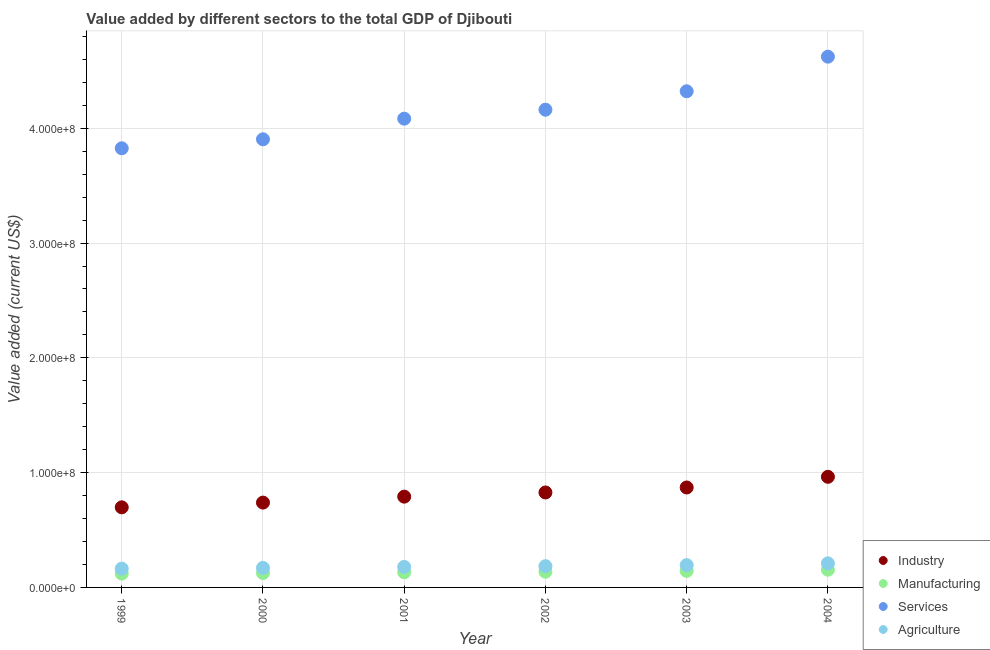How many different coloured dotlines are there?
Offer a terse response. 4. What is the value added by industrial sector in 2003?
Your answer should be very brief. 8.71e+07. Across all years, what is the maximum value added by manufacturing sector?
Offer a terse response. 1.54e+07. Across all years, what is the minimum value added by industrial sector?
Make the answer very short. 6.98e+07. In which year was the value added by industrial sector maximum?
Offer a very short reply. 2004. What is the total value added by agricultural sector in the graph?
Provide a short and direct response. 1.10e+08. What is the difference between the value added by manufacturing sector in 2002 and that in 2003?
Ensure brevity in your answer.  -7.02e+05. What is the difference between the value added by industrial sector in 1999 and the value added by manufacturing sector in 2004?
Your response must be concise. 5.44e+07. What is the average value added by services sector per year?
Keep it short and to the point. 4.15e+08. In the year 1999, what is the difference between the value added by manufacturing sector and value added by services sector?
Your answer should be compact. -3.70e+08. What is the ratio of the value added by agricultural sector in 2001 to that in 2003?
Provide a succinct answer. 0.92. Is the value added by manufacturing sector in 1999 less than that in 2003?
Provide a succinct answer. Yes. What is the difference between the highest and the second highest value added by agricultural sector?
Your answer should be very brief. 1.51e+06. What is the difference between the highest and the lowest value added by agricultural sector?
Offer a very short reply. 4.62e+06. In how many years, is the value added by manufacturing sector greater than the average value added by manufacturing sector taken over all years?
Your answer should be very brief. 3. Is the sum of the value added by industrial sector in 2000 and 2001 greater than the maximum value added by services sector across all years?
Your response must be concise. No. Is the value added by agricultural sector strictly greater than the value added by industrial sector over the years?
Your response must be concise. No. Is the value added by industrial sector strictly less than the value added by services sector over the years?
Ensure brevity in your answer.  Yes. Does the graph contain any zero values?
Offer a very short reply. No. What is the title of the graph?
Keep it short and to the point. Value added by different sectors to the total GDP of Djibouti. What is the label or title of the Y-axis?
Offer a very short reply. Value added (current US$). What is the Value added (current US$) in Industry in 1999?
Offer a terse response. 6.98e+07. What is the Value added (current US$) in Manufacturing in 1999?
Give a very brief answer. 1.21e+07. What is the Value added (current US$) of Services in 1999?
Keep it short and to the point. 3.83e+08. What is the Value added (current US$) in Agriculture in 1999?
Your answer should be very brief. 1.64e+07. What is the Value added (current US$) in Industry in 2000?
Your answer should be very brief. 7.39e+07. What is the Value added (current US$) of Manufacturing in 2000?
Make the answer very short. 1.26e+07. What is the Value added (current US$) in Services in 2000?
Make the answer very short. 3.90e+08. What is the Value added (current US$) in Agriculture in 2000?
Give a very brief answer. 1.71e+07. What is the Value added (current US$) of Industry in 2001?
Your response must be concise. 7.91e+07. What is the Value added (current US$) in Manufacturing in 2001?
Your response must be concise. 1.32e+07. What is the Value added (current US$) in Services in 2001?
Make the answer very short. 4.08e+08. What is the Value added (current US$) of Agriculture in 2001?
Give a very brief answer. 1.79e+07. What is the Value added (current US$) of Industry in 2002?
Offer a terse response. 8.27e+07. What is the Value added (current US$) in Manufacturing in 2002?
Provide a succinct answer. 1.37e+07. What is the Value added (current US$) in Services in 2002?
Your answer should be compact. 4.16e+08. What is the Value added (current US$) in Agriculture in 2002?
Your answer should be very brief. 1.85e+07. What is the Value added (current US$) in Industry in 2003?
Your answer should be very brief. 8.71e+07. What is the Value added (current US$) of Manufacturing in 2003?
Give a very brief answer. 1.44e+07. What is the Value added (current US$) of Services in 2003?
Provide a succinct answer. 4.32e+08. What is the Value added (current US$) in Agriculture in 2003?
Provide a short and direct response. 1.95e+07. What is the Value added (current US$) of Industry in 2004?
Ensure brevity in your answer.  9.64e+07. What is the Value added (current US$) of Manufacturing in 2004?
Keep it short and to the point. 1.54e+07. What is the Value added (current US$) of Services in 2004?
Give a very brief answer. 4.62e+08. What is the Value added (current US$) in Agriculture in 2004?
Provide a succinct answer. 2.10e+07. Across all years, what is the maximum Value added (current US$) in Industry?
Ensure brevity in your answer.  9.64e+07. Across all years, what is the maximum Value added (current US$) in Manufacturing?
Ensure brevity in your answer.  1.54e+07. Across all years, what is the maximum Value added (current US$) of Services?
Your answer should be very brief. 4.62e+08. Across all years, what is the maximum Value added (current US$) in Agriculture?
Provide a short and direct response. 2.10e+07. Across all years, what is the minimum Value added (current US$) of Industry?
Ensure brevity in your answer.  6.98e+07. Across all years, what is the minimum Value added (current US$) of Manufacturing?
Offer a very short reply. 1.21e+07. Across all years, what is the minimum Value added (current US$) of Services?
Your response must be concise. 3.83e+08. Across all years, what is the minimum Value added (current US$) in Agriculture?
Keep it short and to the point. 1.64e+07. What is the total Value added (current US$) in Industry in the graph?
Offer a terse response. 4.89e+08. What is the total Value added (current US$) of Manufacturing in the graph?
Offer a terse response. 8.13e+07. What is the total Value added (current US$) of Services in the graph?
Make the answer very short. 2.49e+09. What is the total Value added (current US$) of Agriculture in the graph?
Offer a terse response. 1.10e+08. What is the difference between the Value added (current US$) of Industry in 1999 and that in 2000?
Your answer should be compact. -4.11e+06. What is the difference between the Value added (current US$) of Manufacturing in 1999 and that in 2000?
Give a very brief answer. -4.83e+05. What is the difference between the Value added (current US$) in Services in 1999 and that in 2000?
Provide a succinct answer. -7.82e+06. What is the difference between the Value added (current US$) of Agriculture in 1999 and that in 2000?
Ensure brevity in your answer.  -7.03e+05. What is the difference between the Value added (current US$) in Industry in 1999 and that in 2001?
Provide a succinct answer. -9.30e+06. What is the difference between the Value added (current US$) of Manufacturing in 1999 and that in 2001?
Give a very brief answer. -1.10e+06. What is the difference between the Value added (current US$) of Services in 1999 and that in 2001?
Keep it short and to the point. -2.58e+07. What is the difference between the Value added (current US$) of Agriculture in 1999 and that in 2001?
Offer a terse response. -1.52e+06. What is the difference between the Value added (current US$) in Industry in 1999 and that in 2002?
Give a very brief answer. -1.29e+07. What is the difference between the Value added (current US$) in Manufacturing in 1999 and that in 2002?
Keep it short and to the point. -1.60e+06. What is the difference between the Value added (current US$) of Services in 1999 and that in 2002?
Provide a succinct answer. -3.36e+07. What is the difference between the Value added (current US$) of Agriculture in 1999 and that in 2002?
Ensure brevity in your answer.  -2.18e+06. What is the difference between the Value added (current US$) in Industry in 1999 and that in 2003?
Provide a succinct answer. -1.73e+07. What is the difference between the Value added (current US$) of Manufacturing in 1999 and that in 2003?
Your response must be concise. -2.30e+06. What is the difference between the Value added (current US$) in Services in 1999 and that in 2003?
Give a very brief answer. -4.97e+07. What is the difference between the Value added (current US$) of Agriculture in 1999 and that in 2003?
Keep it short and to the point. -3.11e+06. What is the difference between the Value added (current US$) in Industry in 1999 and that in 2004?
Ensure brevity in your answer.  -2.66e+07. What is the difference between the Value added (current US$) in Manufacturing in 1999 and that in 2004?
Provide a succinct answer. -3.34e+06. What is the difference between the Value added (current US$) in Services in 1999 and that in 2004?
Your answer should be compact. -7.98e+07. What is the difference between the Value added (current US$) in Agriculture in 1999 and that in 2004?
Provide a succinct answer. -4.62e+06. What is the difference between the Value added (current US$) of Industry in 2000 and that in 2001?
Ensure brevity in your answer.  -5.19e+06. What is the difference between the Value added (current US$) in Manufacturing in 2000 and that in 2001?
Keep it short and to the point. -6.18e+05. What is the difference between the Value added (current US$) of Services in 2000 and that in 2001?
Provide a short and direct response. -1.80e+07. What is the difference between the Value added (current US$) of Agriculture in 2000 and that in 2001?
Your response must be concise. -8.21e+05. What is the difference between the Value added (current US$) in Industry in 2000 and that in 2002?
Ensure brevity in your answer.  -8.84e+06. What is the difference between the Value added (current US$) of Manufacturing in 2000 and that in 2002?
Give a very brief answer. -1.11e+06. What is the difference between the Value added (current US$) in Services in 2000 and that in 2002?
Make the answer very short. -2.58e+07. What is the difference between the Value added (current US$) of Agriculture in 2000 and that in 2002?
Provide a short and direct response. -1.47e+06. What is the difference between the Value added (current US$) of Industry in 2000 and that in 2003?
Offer a terse response. -1.32e+07. What is the difference between the Value added (current US$) of Manufacturing in 2000 and that in 2003?
Your answer should be compact. -1.81e+06. What is the difference between the Value added (current US$) in Services in 2000 and that in 2003?
Provide a succinct answer. -4.19e+07. What is the difference between the Value added (current US$) of Agriculture in 2000 and that in 2003?
Offer a terse response. -2.41e+06. What is the difference between the Value added (current US$) in Industry in 2000 and that in 2004?
Your response must be concise. -2.25e+07. What is the difference between the Value added (current US$) of Manufacturing in 2000 and that in 2004?
Provide a short and direct response. -2.86e+06. What is the difference between the Value added (current US$) of Services in 2000 and that in 2004?
Make the answer very short. -7.20e+07. What is the difference between the Value added (current US$) in Agriculture in 2000 and that in 2004?
Offer a terse response. -3.92e+06. What is the difference between the Value added (current US$) in Industry in 2001 and that in 2002?
Your answer should be compact. -3.65e+06. What is the difference between the Value added (current US$) in Manufacturing in 2001 and that in 2002?
Make the answer very short. -4.95e+05. What is the difference between the Value added (current US$) of Services in 2001 and that in 2002?
Ensure brevity in your answer.  -7.81e+06. What is the difference between the Value added (current US$) of Agriculture in 2001 and that in 2002?
Your answer should be very brief. -6.53e+05. What is the difference between the Value added (current US$) in Industry in 2001 and that in 2003?
Provide a short and direct response. -7.98e+06. What is the difference between the Value added (current US$) of Manufacturing in 2001 and that in 2003?
Offer a terse response. -1.20e+06. What is the difference between the Value added (current US$) in Services in 2001 and that in 2003?
Give a very brief answer. -2.39e+07. What is the difference between the Value added (current US$) of Agriculture in 2001 and that in 2003?
Keep it short and to the point. -1.59e+06. What is the difference between the Value added (current US$) in Industry in 2001 and that in 2004?
Your answer should be compact. -1.73e+07. What is the difference between the Value added (current US$) in Manufacturing in 2001 and that in 2004?
Offer a terse response. -2.24e+06. What is the difference between the Value added (current US$) of Services in 2001 and that in 2004?
Your answer should be compact. -5.40e+07. What is the difference between the Value added (current US$) of Agriculture in 2001 and that in 2004?
Give a very brief answer. -3.10e+06. What is the difference between the Value added (current US$) of Industry in 2002 and that in 2003?
Make the answer very short. -4.33e+06. What is the difference between the Value added (current US$) of Manufacturing in 2002 and that in 2003?
Provide a succinct answer. -7.02e+05. What is the difference between the Value added (current US$) in Services in 2002 and that in 2003?
Offer a very short reply. -1.61e+07. What is the difference between the Value added (current US$) of Agriculture in 2002 and that in 2003?
Offer a very short reply. -9.32e+05. What is the difference between the Value added (current US$) in Industry in 2002 and that in 2004?
Give a very brief answer. -1.36e+07. What is the difference between the Value added (current US$) in Manufacturing in 2002 and that in 2004?
Offer a terse response. -1.75e+06. What is the difference between the Value added (current US$) of Services in 2002 and that in 2004?
Offer a terse response. -4.62e+07. What is the difference between the Value added (current US$) of Agriculture in 2002 and that in 2004?
Make the answer very short. -2.44e+06. What is the difference between the Value added (current US$) in Industry in 2003 and that in 2004?
Your answer should be compact. -9.30e+06. What is the difference between the Value added (current US$) of Manufacturing in 2003 and that in 2004?
Your answer should be very brief. -1.04e+06. What is the difference between the Value added (current US$) of Services in 2003 and that in 2004?
Provide a succinct answer. -3.01e+07. What is the difference between the Value added (current US$) in Agriculture in 2003 and that in 2004?
Offer a terse response. -1.51e+06. What is the difference between the Value added (current US$) in Industry in 1999 and the Value added (current US$) in Manufacturing in 2000?
Ensure brevity in your answer.  5.72e+07. What is the difference between the Value added (current US$) in Industry in 1999 and the Value added (current US$) in Services in 2000?
Your answer should be compact. -3.21e+08. What is the difference between the Value added (current US$) of Industry in 1999 and the Value added (current US$) of Agriculture in 2000?
Provide a succinct answer. 5.27e+07. What is the difference between the Value added (current US$) in Manufacturing in 1999 and the Value added (current US$) in Services in 2000?
Provide a succinct answer. -3.78e+08. What is the difference between the Value added (current US$) in Manufacturing in 1999 and the Value added (current US$) in Agriculture in 2000?
Provide a short and direct response. -4.97e+06. What is the difference between the Value added (current US$) in Services in 1999 and the Value added (current US$) in Agriculture in 2000?
Ensure brevity in your answer.  3.66e+08. What is the difference between the Value added (current US$) of Industry in 1999 and the Value added (current US$) of Manufacturing in 2001?
Offer a terse response. 5.66e+07. What is the difference between the Value added (current US$) of Industry in 1999 and the Value added (current US$) of Services in 2001?
Your response must be concise. -3.39e+08. What is the difference between the Value added (current US$) of Industry in 1999 and the Value added (current US$) of Agriculture in 2001?
Your answer should be compact. 5.19e+07. What is the difference between the Value added (current US$) in Manufacturing in 1999 and the Value added (current US$) in Services in 2001?
Provide a short and direct response. -3.96e+08. What is the difference between the Value added (current US$) of Manufacturing in 1999 and the Value added (current US$) of Agriculture in 2001?
Give a very brief answer. -5.80e+06. What is the difference between the Value added (current US$) of Services in 1999 and the Value added (current US$) of Agriculture in 2001?
Provide a succinct answer. 3.65e+08. What is the difference between the Value added (current US$) in Industry in 1999 and the Value added (current US$) in Manufacturing in 2002?
Your answer should be very brief. 5.61e+07. What is the difference between the Value added (current US$) in Industry in 1999 and the Value added (current US$) in Services in 2002?
Give a very brief answer. -3.46e+08. What is the difference between the Value added (current US$) of Industry in 1999 and the Value added (current US$) of Agriculture in 2002?
Ensure brevity in your answer.  5.13e+07. What is the difference between the Value added (current US$) in Manufacturing in 1999 and the Value added (current US$) in Services in 2002?
Give a very brief answer. -4.04e+08. What is the difference between the Value added (current US$) in Manufacturing in 1999 and the Value added (current US$) in Agriculture in 2002?
Your answer should be very brief. -6.45e+06. What is the difference between the Value added (current US$) of Services in 1999 and the Value added (current US$) of Agriculture in 2002?
Keep it short and to the point. 3.64e+08. What is the difference between the Value added (current US$) in Industry in 1999 and the Value added (current US$) in Manufacturing in 2003?
Your answer should be very brief. 5.54e+07. What is the difference between the Value added (current US$) of Industry in 1999 and the Value added (current US$) of Services in 2003?
Ensure brevity in your answer.  -3.62e+08. What is the difference between the Value added (current US$) of Industry in 1999 and the Value added (current US$) of Agriculture in 2003?
Make the answer very short. 5.03e+07. What is the difference between the Value added (current US$) of Manufacturing in 1999 and the Value added (current US$) of Services in 2003?
Provide a short and direct response. -4.20e+08. What is the difference between the Value added (current US$) of Manufacturing in 1999 and the Value added (current US$) of Agriculture in 2003?
Offer a terse response. -7.38e+06. What is the difference between the Value added (current US$) in Services in 1999 and the Value added (current US$) in Agriculture in 2003?
Offer a terse response. 3.63e+08. What is the difference between the Value added (current US$) of Industry in 1999 and the Value added (current US$) of Manufacturing in 2004?
Provide a short and direct response. 5.44e+07. What is the difference between the Value added (current US$) of Industry in 1999 and the Value added (current US$) of Services in 2004?
Provide a succinct answer. -3.93e+08. What is the difference between the Value added (current US$) of Industry in 1999 and the Value added (current US$) of Agriculture in 2004?
Ensure brevity in your answer.  4.88e+07. What is the difference between the Value added (current US$) of Manufacturing in 1999 and the Value added (current US$) of Services in 2004?
Give a very brief answer. -4.50e+08. What is the difference between the Value added (current US$) of Manufacturing in 1999 and the Value added (current US$) of Agriculture in 2004?
Your answer should be compact. -8.89e+06. What is the difference between the Value added (current US$) of Services in 1999 and the Value added (current US$) of Agriculture in 2004?
Provide a succinct answer. 3.62e+08. What is the difference between the Value added (current US$) in Industry in 2000 and the Value added (current US$) in Manufacturing in 2001?
Your answer should be very brief. 6.07e+07. What is the difference between the Value added (current US$) of Industry in 2000 and the Value added (current US$) of Services in 2001?
Ensure brevity in your answer.  -3.34e+08. What is the difference between the Value added (current US$) in Industry in 2000 and the Value added (current US$) in Agriculture in 2001?
Offer a very short reply. 5.60e+07. What is the difference between the Value added (current US$) in Manufacturing in 2000 and the Value added (current US$) in Services in 2001?
Offer a terse response. -3.96e+08. What is the difference between the Value added (current US$) of Manufacturing in 2000 and the Value added (current US$) of Agriculture in 2001?
Your response must be concise. -5.31e+06. What is the difference between the Value added (current US$) in Services in 2000 and the Value added (current US$) in Agriculture in 2001?
Provide a succinct answer. 3.73e+08. What is the difference between the Value added (current US$) in Industry in 2000 and the Value added (current US$) in Manufacturing in 2002?
Make the answer very short. 6.02e+07. What is the difference between the Value added (current US$) of Industry in 2000 and the Value added (current US$) of Services in 2002?
Offer a terse response. -3.42e+08. What is the difference between the Value added (current US$) in Industry in 2000 and the Value added (current US$) in Agriculture in 2002?
Your response must be concise. 5.54e+07. What is the difference between the Value added (current US$) in Manufacturing in 2000 and the Value added (current US$) in Services in 2002?
Provide a succinct answer. -4.04e+08. What is the difference between the Value added (current US$) of Manufacturing in 2000 and the Value added (current US$) of Agriculture in 2002?
Give a very brief answer. -5.96e+06. What is the difference between the Value added (current US$) of Services in 2000 and the Value added (current US$) of Agriculture in 2002?
Provide a short and direct response. 3.72e+08. What is the difference between the Value added (current US$) in Industry in 2000 and the Value added (current US$) in Manufacturing in 2003?
Provide a succinct answer. 5.95e+07. What is the difference between the Value added (current US$) of Industry in 2000 and the Value added (current US$) of Services in 2003?
Provide a succinct answer. -3.58e+08. What is the difference between the Value added (current US$) of Industry in 2000 and the Value added (current US$) of Agriculture in 2003?
Provide a short and direct response. 5.44e+07. What is the difference between the Value added (current US$) of Manufacturing in 2000 and the Value added (current US$) of Services in 2003?
Your response must be concise. -4.20e+08. What is the difference between the Value added (current US$) in Manufacturing in 2000 and the Value added (current US$) in Agriculture in 2003?
Ensure brevity in your answer.  -6.90e+06. What is the difference between the Value added (current US$) in Services in 2000 and the Value added (current US$) in Agriculture in 2003?
Provide a short and direct response. 3.71e+08. What is the difference between the Value added (current US$) of Industry in 2000 and the Value added (current US$) of Manufacturing in 2004?
Your answer should be very brief. 5.85e+07. What is the difference between the Value added (current US$) of Industry in 2000 and the Value added (current US$) of Services in 2004?
Your answer should be compact. -3.88e+08. What is the difference between the Value added (current US$) in Industry in 2000 and the Value added (current US$) in Agriculture in 2004?
Provide a short and direct response. 5.29e+07. What is the difference between the Value added (current US$) of Manufacturing in 2000 and the Value added (current US$) of Services in 2004?
Give a very brief answer. -4.50e+08. What is the difference between the Value added (current US$) of Manufacturing in 2000 and the Value added (current US$) of Agriculture in 2004?
Provide a short and direct response. -8.41e+06. What is the difference between the Value added (current US$) in Services in 2000 and the Value added (current US$) in Agriculture in 2004?
Ensure brevity in your answer.  3.69e+08. What is the difference between the Value added (current US$) of Industry in 2001 and the Value added (current US$) of Manufacturing in 2002?
Offer a very short reply. 6.54e+07. What is the difference between the Value added (current US$) in Industry in 2001 and the Value added (current US$) in Services in 2002?
Offer a terse response. -3.37e+08. What is the difference between the Value added (current US$) in Industry in 2001 and the Value added (current US$) in Agriculture in 2002?
Offer a terse response. 6.06e+07. What is the difference between the Value added (current US$) in Manufacturing in 2001 and the Value added (current US$) in Services in 2002?
Offer a terse response. -4.03e+08. What is the difference between the Value added (current US$) in Manufacturing in 2001 and the Value added (current US$) in Agriculture in 2002?
Your answer should be compact. -5.35e+06. What is the difference between the Value added (current US$) in Services in 2001 and the Value added (current US$) in Agriculture in 2002?
Your answer should be compact. 3.90e+08. What is the difference between the Value added (current US$) of Industry in 2001 and the Value added (current US$) of Manufacturing in 2003?
Your answer should be compact. 6.47e+07. What is the difference between the Value added (current US$) of Industry in 2001 and the Value added (current US$) of Services in 2003?
Your answer should be compact. -3.53e+08. What is the difference between the Value added (current US$) in Industry in 2001 and the Value added (current US$) in Agriculture in 2003?
Your answer should be compact. 5.96e+07. What is the difference between the Value added (current US$) in Manufacturing in 2001 and the Value added (current US$) in Services in 2003?
Make the answer very short. -4.19e+08. What is the difference between the Value added (current US$) in Manufacturing in 2001 and the Value added (current US$) in Agriculture in 2003?
Provide a succinct answer. -6.28e+06. What is the difference between the Value added (current US$) of Services in 2001 and the Value added (current US$) of Agriculture in 2003?
Give a very brief answer. 3.89e+08. What is the difference between the Value added (current US$) of Industry in 2001 and the Value added (current US$) of Manufacturing in 2004?
Your answer should be very brief. 6.37e+07. What is the difference between the Value added (current US$) in Industry in 2001 and the Value added (current US$) in Services in 2004?
Your answer should be very brief. -3.83e+08. What is the difference between the Value added (current US$) of Industry in 2001 and the Value added (current US$) of Agriculture in 2004?
Provide a succinct answer. 5.81e+07. What is the difference between the Value added (current US$) in Manufacturing in 2001 and the Value added (current US$) in Services in 2004?
Ensure brevity in your answer.  -4.49e+08. What is the difference between the Value added (current US$) of Manufacturing in 2001 and the Value added (current US$) of Agriculture in 2004?
Offer a terse response. -7.79e+06. What is the difference between the Value added (current US$) in Services in 2001 and the Value added (current US$) in Agriculture in 2004?
Your answer should be compact. 3.87e+08. What is the difference between the Value added (current US$) of Industry in 2002 and the Value added (current US$) of Manufacturing in 2003?
Your response must be concise. 6.84e+07. What is the difference between the Value added (current US$) of Industry in 2002 and the Value added (current US$) of Services in 2003?
Make the answer very short. -3.50e+08. What is the difference between the Value added (current US$) of Industry in 2002 and the Value added (current US$) of Agriculture in 2003?
Your answer should be very brief. 6.33e+07. What is the difference between the Value added (current US$) in Manufacturing in 2002 and the Value added (current US$) in Services in 2003?
Your answer should be compact. -4.19e+08. What is the difference between the Value added (current US$) of Manufacturing in 2002 and the Value added (current US$) of Agriculture in 2003?
Offer a terse response. -5.78e+06. What is the difference between the Value added (current US$) in Services in 2002 and the Value added (current US$) in Agriculture in 2003?
Your response must be concise. 3.97e+08. What is the difference between the Value added (current US$) in Industry in 2002 and the Value added (current US$) in Manufacturing in 2004?
Ensure brevity in your answer.  6.73e+07. What is the difference between the Value added (current US$) in Industry in 2002 and the Value added (current US$) in Services in 2004?
Keep it short and to the point. -3.80e+08. What is the difference between the Value added (current US$) of Industry in 2002 and the Value added (current US$) of Agriculture in 2004?
Provide a succinct answer. 6.18e+07. What is the difference between the Value added (current US$) of Manufacturing in 2002 and the Value added (current US$) of Services in 2004?
Your answer should be compact. -4.49e+08. What is the difference between the Value added (current US$) of Manufacturing in 2002 and the Value added (current US$) of Agriculture in 2004?
Your response must be concise. -7.29e+06. What is the difference between the Value added (current US$) of Services in 2002 and the Value added (current US$) of Agriculture in 2004?
Your answer should be compact. 3.95e+08. What is the difference between the Value added (current US$) of Industry in 2003 and the Value added (current US$) of Manufacturing in 2004?
Ensure brevity in your answer.  7.16e+07. What is the difference between the Value added (current US$) of Industry in 2003 and the Value added (current US$) of Services in 2004?
Provide a short and direct response. -3.75e+08. What is the difference between the Value added (current US$) in Industry in 2003 and the Value added (current US$) in Agriculture in 2004?
Keep it short and to the point. 6.61e+07. What is the difference between the Value added (current US$) in Manufacturing in 2003 and the Value added (current US$) in Services in 2004?
Your response must be concise. -4.48e+08. What is the difference between the Value added (current US$) of Manufacturing in 2003 and the Value added (current US$) of Agriculture in 2004?
Make the answer very short. -6.59e+06. What is the difference between the Value added (current US$) in Services in 2003 and the Value added (current US$) in Agriculture in 2004?
Make the answer very short. 4.11e+08. What is the average Value added (current US$) in Industry per year?
Provide a short and direct response. 8.15e+07. What is the average Value added (current US$) in Manufacturing per year?
Your answer should be compact. 1.36e+07. What is the average Value added (current US$) in Services per year?
Make the answer very short. 4.15e+08. What is the average Value added (current US$) in Agriculture per year?
Offer a very short reply. 1.84e+07. In the year 1999, what is the difference between the Value added (current US$) in Industry and Value added (current US$) in Manufacturing?
Keep it short and to the point. 5.77e+07. In the year 1999, what is the difference between the Value added (current US$) of Industry and Value added (current US$) of Services?
Your answer should be compact. -3.13e+08. In the year 1999, what is the difference between the Value added (current US$) of Industry and Value added (current US$) of Agriculture?
Provide a short and direct response. 5.34e+07. In the year 1999, what is the difference between the Value added (current US$) of Manufacturing and Value added (current US$) of Services?
Ensure brevity in your answer.  -3.70e+08. In the year 1999, what is the difference between the Value added (current US$) in Manufacturing and Value added (current US$) in Agriculture?
Give a very brief answer. -4.27e+06. In the year 1999, what is the difference between the Value added (current US$) of Services and Value added (current US$) of Agriculture?
Provide a short and direct response. 3.66e+08. In the year 2000, what is the difference between the Value added (current US$) of Industry and Value added (current US$) of Manufacturing?
Make the answer very short. 6.13e+07. In the year 2000, what is the difference between the Value added (current US$) in Industry and Value added (current US$) in Services?
Provide a short and direct response. -3.17e+08. In the year 2000, what is the difference between the Value added (current US$) in Industry and Value added (current US$) in Agriculture?
Your answer should be compact. 5.68e+07. In the year 2000, what is the difference between the Value added (current US$) of Manufacturing and Value added (current US$) of Services?
Provide a succinct answer. -3.78e+08. In the year 2000, what is the difference between the Value added (current US$) in Manufacturing and Value added (current US$) in Agriculture?
Keep it short and to the point. -4.49e+06. In the year 2000, what is the difference between the Value added (current US$) of Services and Value added (current US$) of Agriculture?
Your response must be concise. 3.73e+08. In the year 2001, what is the difference between the Value added (current US$) of Industry and Value added (current US$) of Manufacturing?
Make the answer very short. 6.59e+07. In the year 2001, what is the difference between the Value added (current US$) of Industry and Value added (current US$) of Services?
Offer a terse response. -3.29e+08. In the year 2001, what is the difference between the Value added (current US$) in Industry and Value added (current US$) in Agriculture?
Provide a short and direct response. 6.12e+07. In the year 2001, what is the difference between the Value added (current US$) of Manufacturing and Value added (current US$) of Services?
Your answer should be compact. -3.95e+08. In the year 2001, what is the difference between the Value added (current US$) in Manufacturing and Value added (current US$) in Agriculture?
Give a very brief answer. -4.69e+06. In the year 2001, what is the difference between the Value added (current US$) in Services and Value added (current US$) in Agriculture?
Provide a short and direct response. 3.91e+08. In the year 2002, what is the difference between the Value added (current US$) of Industry and Value added (current US$) of Manufacturing?
Your answer should be compact. 6.91e+07. In the year 2002, what is the difference between the Value added (current US$) of Industry and Value added (current US$) of Services?
Ensure brevity in your answer.  -3.33e+08. In the year 2002, what is the difference between the Value added (current US$) of Industry and Value added (current US$) of Agriculture?
Ensure brevity in your answer.  6.42e+07. In the year 2002, what is the difference between the Value added (current US$) in Manufacturing and Value added (current US$) in Services?
Your answer should be very brief. -4.03e+08. In the year 2002, what is the difference between the Value added (current US$) in Manufacturing and Value added (current US$) in Agriculture?
Ensure brevity in your answer.  -4.85e+06. In the year 2002, what is the difference between the Value added (current US$) in Services and Value added (current US$) in Agriculture?
Keep it short and to the point. 3.98e+08. In the year 2003, what is the difference between the Value added (current US$) of Industry and Value added (current US$) of Manufacturing?
Give a very brief answer. 7.27e+07. In the year 2003, what is the difference between the Value added (current US$) in Industry and Value added (current US$) in Services?
Offer a very short reply. -3.45e+08. In the year 2003, what is the difference between the Value added (current US$) in Industry and Value added (current US$) in Agriculture?
Provide a short and direct response. 6.76e+07. In the year 2003, what is the difference between the Value added (current US$) in Manufacturing and Value added (current US$) in Services?
Give a very brief answer. -4.18e+08. In the year 2003, what is the difference between the Value added (current US$) of Manufacturing and Value added (current US$) of Agriculture?
Offer a terse response. -5.08e+06. In the year 2003, what is the difference between the Value added (current US$) of Services and Value added (current US$) of Agriculture?
Give a very brief answer. 4.13e+08. In the year 2004, what is the difference between the Value added (current US$) of Industry and Value added (current US$) of Manufacturing?
Your response must be concise. 8.09e+07. In the year 2004, what is the difference between the Value added (current US$) in Industry and Value added (current US$) in Services?
Ensure brevity in your answer.  -3.66e+08. In the year 2004, what is the difference between the Value added (current US$) in Industry and Value added (current US$) in Agriculture?
Offer a terse response. 7.54e+07. In the year 2004, what is the difference between the Value added (current US$) in Manufacturing and Value added (current US$) in Services?
Offer a very short reply. -4.47e+08. In the year 2004, what is the difference between the Value added (current US$) in Manufacturing and Value added (current US$) in Agriculture?
Offer a terse response. -5.55e+06. In the year 2004, what is the difference between the Value added (current US$) of Services and Value added (current US$) of Agriculture?
Offer a very short reply. 4.41e+08. What is the ratio of the Value added (current US$) in Manufacturing in 1999 to that in 2000?
Make the answer very short. 0.96. What is the ratio of the Value added (current US$) in Agriculture in 1999 to that in 2000?
Your answer should be very brief. 0.96. What is the ratio of the Value added (current US$) in Industry in 1999 to that in 2001?
Ensure brevity in your answer.  0.88. What is the ratio of the Value added (current US$) in Manufacturing in 1999 to that in 2001?
Make the answer very short. 0.92. What is the ratio of the Value added (current US$) in Services in 1999 to that in 2001?
Offer a terse response. 0.94. What is the ratio of the Value added (current US$) in Agriculture in 1999 to that in 2001?
Offer a very short reply. 0.91. What is the ratio of the Value added (current US$) of Industry in 1999 to that in 2002?
Keep it short and to the point. 0.84. What is the ratio of the Value added (current US$) in Manufacturing in 1999 to that in 2002?
Your response must be concise. 0.88. What is the ratio of the Value added (current US$) of Services in 1999 to that in 2002?
Offer a very short reply. 0.92. What is the ratio of the Value added (current US$) in Agriculture in 1999 to that in 2002?
Offer a very short reply. 0.88. What is the ratio of the Value added (current US$) in Industry in 1999 to that in 2003?
Keep it short and to the point. 0.8. What is the ratio of the Value added (current US$) in Manufacturing in 1999 to that in 2003?
Offer a terse response. 0.84. What is the ratio of the Value added (current US$) of Services in 1999 to that in 2003?
Ensure brevity in your answer.  0.89. What is the ratio of the Value added (current US$) of Agriculture in 1999 to that in 2003?
Provide a short and direct response. 0.84. What is the ratio of the Value added (current US$) of Industry in 1999 to that in 2004?
Offer a terse response. 0.72. What is the ratio of the Value added (current US$) of Manufacturing in 1999 to that in 2004?
Keep it short and to the point. 0.78. What is the ratio of the Value added (current US$) in Services in 1999 to that in 2004?
Make the answer very short. 0.83. What is the ratio of the Value added (current US$) of Agriculture in 1999 to that in 2004?
Give a very brief answer. 0.78. What is the ratio of the Value added (current US$) of Industry in 2000 to that in 2001?
Your response must be concise. 0.93. What is the ratio of the Value added (current US$) in Manufacturing in 2000 to that in 2001?
Ensure brevity in your answer.  0.95. What is the ratio of the Value added (current US$) in Services in 2000 to that in 2001?
Offer a terse response. 0.96. What is the ratio of the Value added (current US$) of Agriculture in 2000 to that in 2001?
Keep it short and to the point. 0.95. What is the ratio of the Value added (current US$) of Industry in 2000 to that in 2002?
Your answer should be compact. 0.89. What is the ratio of the Value added (current US$) of Manufacturing in 2000 to that in 2002?
Ensure brevity in your answer.  0.92. What is the ratio of the Value added (current US$) in Services in 2000 to that in 2002?
Your answer should be compact. 0.94. What is the ratio of the Value added (current US$) of Agriculture in 2000 to that in 2002?
Give a very brief answer. 0.92. What is the ratio of the Value added (current US$) in Industry in 2000 to that in 2003?
Your response must be concise. 0.85. What is the ratio of the Value added (current US$) in Manufacturing in 2000 to that in 2003?
Offer a terse response. 0.87. What is the ratio of the Value added (current US$) in Services in 2000 to that in 2003?
Give a very brief answer. 0.9. What is the ratio of the Value added (current US$) of Agriculture in 2000 to that in 2003?
Keep it short and to the point. 0.88. What is the ratio of the Value added (current US$) of Industry in 2000 to that in 2004?
Make the answer very short. 0.77. What is the ratio of the Value added (current US$) in Manufacturing in 2000 to that in 2004?
Offer a very short reply. 0.81. What is the ratio of the Value added (current US$) of Services in 2000 to that in 2004?
Offer a terse response. 0.84. What is the ratio of the Value added (current US$) of Agriculture in 2000 to that in 2004?
Give a very brief answer. 0.81. What is the ratio of the Value added (current US$) of Industry in 2001 to that in 2002?
Ensure brevity in your answer.  0.96. What is the ratio of the Value added (current US$) of Manufacturing in 2001 to that in 2002?
Provide a short and direct response. 0.96. What is the ratio of the Value added (current US$) of Services in 2001 to that in 2002?
Your answer should be very brief. 0.98. What is the ratio of the Value added (current US$) of Agriculture in 2001 to that in 2002?
Your response must be concise. 0.96. What is the ratio of the Value added (current US$) in Industry in 2001 to that in 2003?
Keep it short and to the point. 0.91. What is the ratio of the Value added (current US$) in Manufacturing in 2001 to that in 2003?
Keep it short and to the point. 0.92. What is the ratio of the Value added (current US$) of Services in 2001 to that in 2003?
Your answer should be compact. 0.94. What is the ratio of the Value added (current US$) in Agriculture in 2001 to that in 2003?
Offer a very short reply. 0.92. What is the ratio of the Value added (current US$) of Industry in 2001 to that in 2004?
Your answer should be very brief. 0.82. What is the ratio of the Value added (current US$) in Manufacturing in 2001 to that in 2004?
Keep it short and to the point. 0.85. What is the ratio of the Value added (current US$) of Services in 2001 to that in 2004?
Provide a succinct answer. 0.88. What is the ratio of the Value added (current US$) of Agriculture in 2001 to that in 2004?
Make the answer very short. 0.85. What is the ratio of the Value added (current US$) of Industry in 2002 to that in 2003?
Your answer should be very brief. 0.95. What is the ratio of the Value added (current US$) of Manufacturing in 2002 to that in 2003?
Your answer should be very brief. 0.95. What is the ratio of the Value added (current US$) of Services in 2002 to that in 2003?
Provide a succinct answer. 0.96. What is the ratio of the Value added (current US$) in Agriculture in 2002 to that in 2003?
Ensure brevity in your answer.  0.95. What is the ratio of the Value added (current US$) in Industry in 2002 to that in 2004?
Your answer should be very brief. 0.86. What is the ratio of the Value added (current US$) in Manufacturing in 2002 to that in 2004?
Offer a terse response. 0.89. What is the ratio of the Value added (current US$) in Services in 2002 to that in 2004?
Your answer should be compact. 0.9. What is the ratio of the Value added (current US$) of Agriculture in 2002 to that in 2004?
Ensure brevity in your answer.  0.88. What is the ratio of the Value added (current US$) in Industry in 2003 to that in 2004?
Give a very brief answer. 0.9. What is the ratio of the Value added (current US$) of Manufacturing in 2003 to that in 2004?
Provide a short and direct response. 0.93. What is the ratio of the Value added (current US$) in Services in 2003 to that in 2004?
Your response must be concise. 0.93. What is the ratio of the Value added (current US$) of Agriculture in 2003 to that in 2004?
Provide a succinct answer. 0.93. What is the difference between the highest and the second highest Value added (current US$) in Industry?
Ensure brevity in your answer.  9.30e+06. What is the difference between the highest and the second highest Value added (current US$) of Manufacturing?
Ensure brevity in your answer.  1.04e+06. What is the difference between the highest and the second highest Value added (current US$) of Services?
Offer a very short reply. 3.01e+07. What is the difference between the highest and the second highest Value added (current US$) of Agriculture?
Your answer should be compact. 1.51e+06. What is the difference between the highest and the lowest Value added (current US$) of Industry?
Give a very brief answer. 2.66e+07. What is the difference between the highest and the lowest Value added (current US$) of Manufacturing?
Make the answer very short. 3.34e+06. What is the difference between the highest and the lowest Value added (current US$) in Services?
Your response must be concise. 7.98e+07. What is the difference between the highest and the lowest Value added (current US$) in Agriculture?
Ensure brevity in your answer.  4.62e+06. 